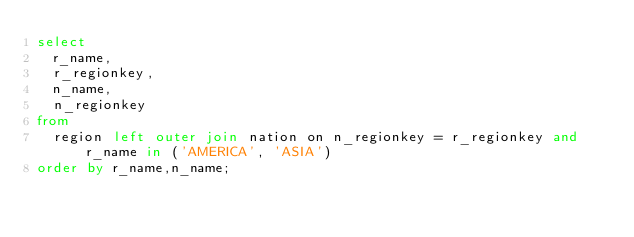<code> <loc_0><loc_0><loc_500><loc_500><_SQL_>select
  r_name,
  r_regionkey,
  n_name,
  n_regionkey
from
  region left outer join nation on n_regionkey = r_regionkey and r_name in ('AMERICA', 'ASIA')
order by r_name,n_name;</code> 